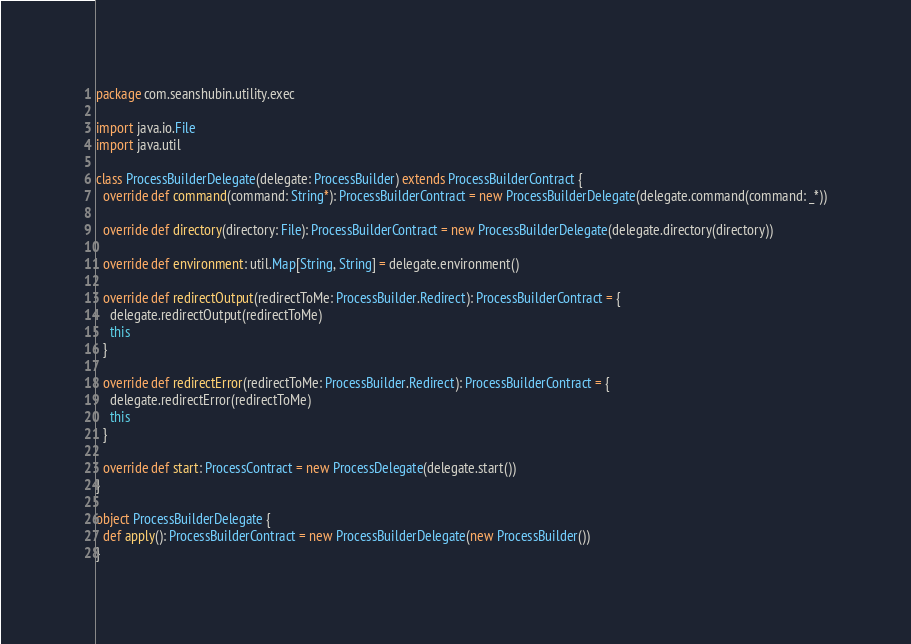Convert code to text. <code><loc_0><loc_0><loc_500><loc_500><_Scala_>package com.seanshubin.utility.exec

import java.io.File
import java.util

class ProcessBuilderDelegate(delegate: ProcessBuilder) extends ProcessBuilderContract {
  override def command(command: String*): ProcessBuilderContract = new ProcessBuilderDelegate(delegate.command(command: _*))

  override def directory(directory: File): ProcessBuilderContract = new ProcessBuilderDelegate(delegate.directory(directory))

  override def environment: util.Map[String, String] = delegate.environment()

  override def redirectOutput(redirectToMe: ProcessBuilder.Redirect): ProcessBuilderContract = {
    delegate.redirectOutput(redirectToMe)
    this
  }

  override def redirectError(redirectToMe: ProcessBuilder.Redirect): ProcessBuilderContract = {
    delegate.redirectError(redirectToMe)
    this
  }

  override def start: ProcessContract = new ProcessDelegate(delegate.start())
}

object ProcessBuilderDelegate {
  def apply(): ProcessBuilderContract = new ProcessBuilderDelegate(new ProcessBuilder())
}
</code> 